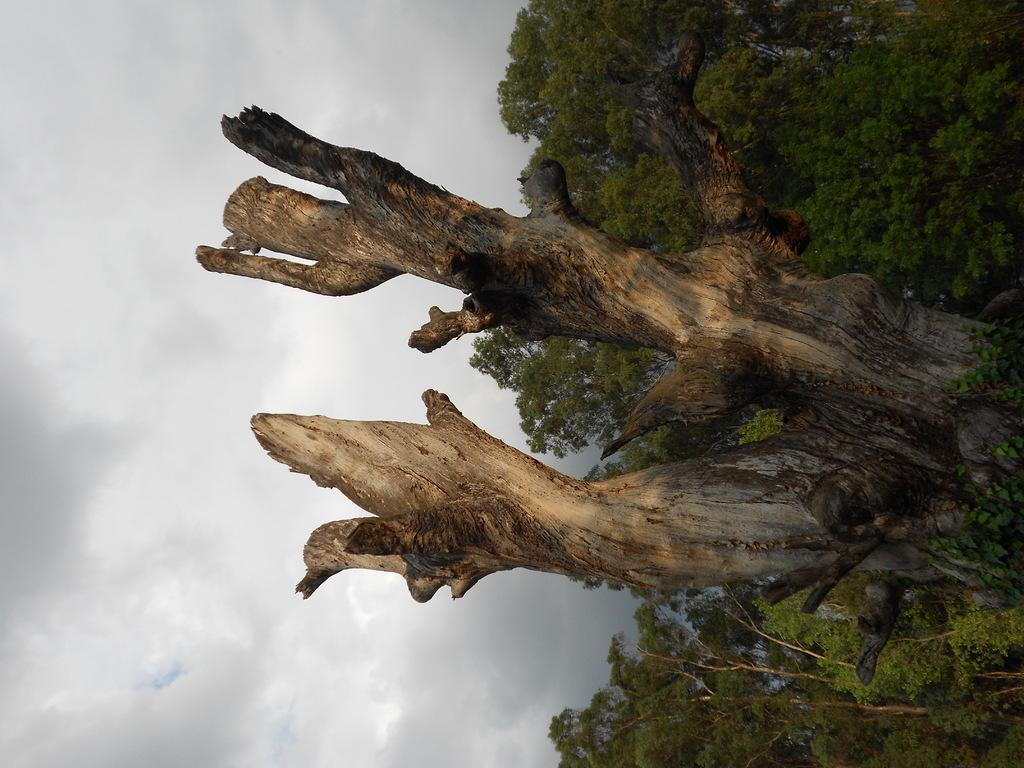What type of vegetation can be seen in the image? There are trees in the image. What object made of wood can be seen in the image? There is a log in the image. What is visible in the background of the image? The sky is visible in the background of the image. How would you describe the weather based on the appearance of the sky? The sky appears to be cloudy, which might suggest overcast or potentially rainy weather. What time of day is it based on the position of the butter in the image? There is no butter present in the image, so it is not possible to determine the time of day based on its position. 